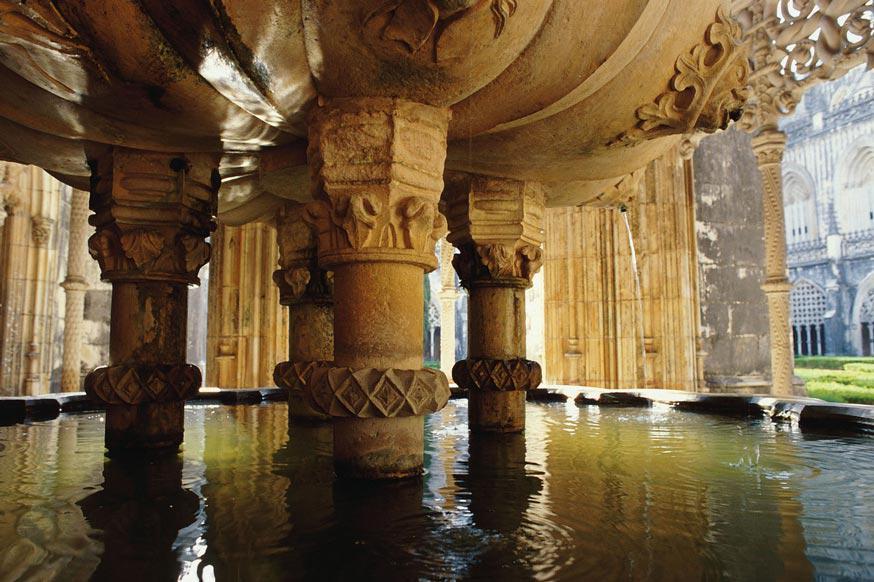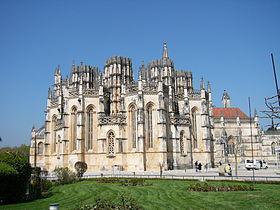The first image is the image on the left, the second image is the image on the right. For the images displayed, is the sentence "An image shows multiple people standing in front of a massive archway." factually correct? Answer yes or no. No. The first image is the image on the left, the second image is the image on the right. Assess this claim about the two images: "The image on the left doesn't show the turrets of the castle.". Correct or not? Answer yes or no. Yes. 